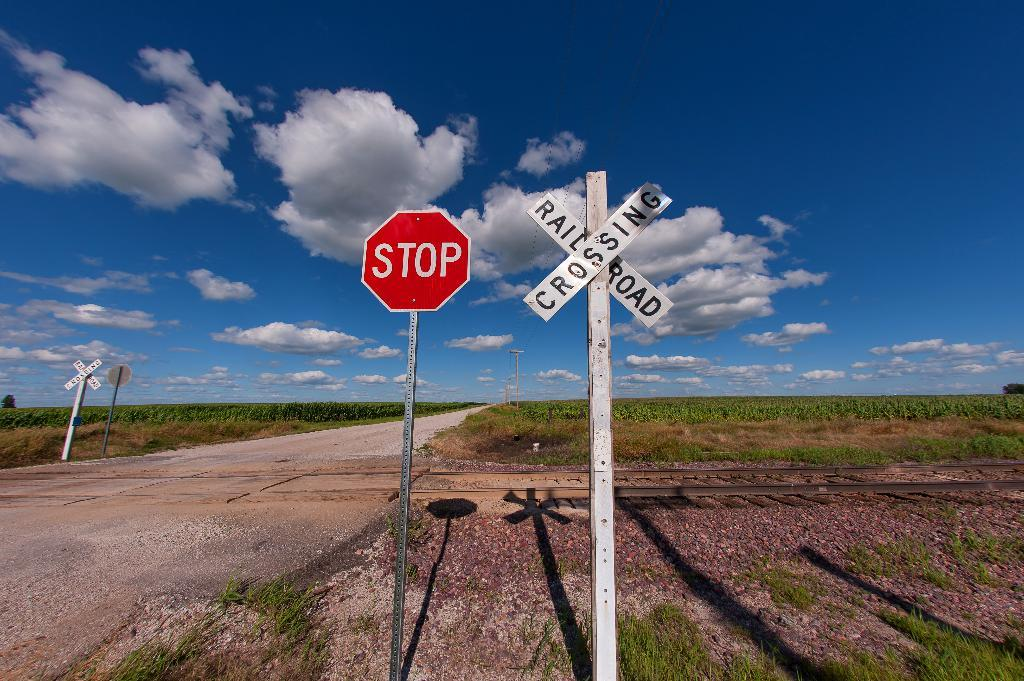Provide a one-sentence caption for the provided image. two signs, one says STOP and the other RAILROAD CROSSING on a long rural roadside. 